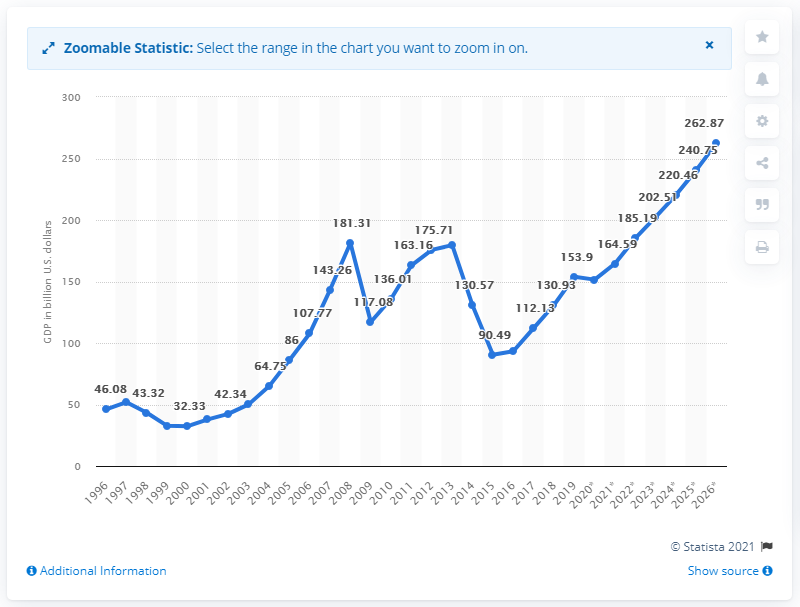Outline some significant characteristics in this image. In 2019, the GDP of Ukraine was 153.9 billion dollars. 